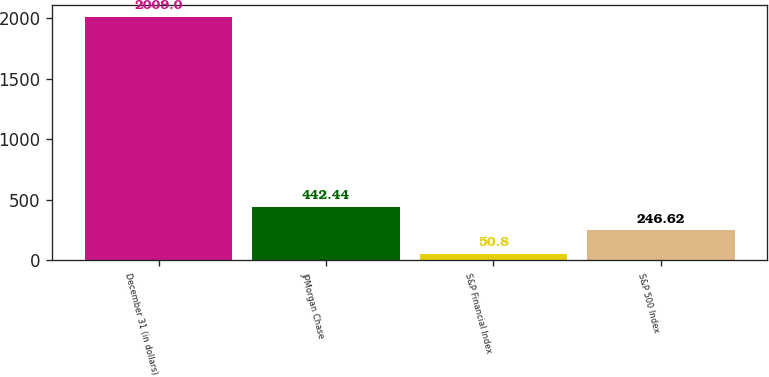<chart> <loc_0><loc_0><loc_500><loc_500><bar_chart><fcel>December 31 (in dollars)<fcel>JPMorgan Chase<fcel>S&P Financial Index<fcel>S&P 500 Index<nl><fcel>2009<fcel>442.44<fcel>50.8<fcel>246.62<nl></chart> 